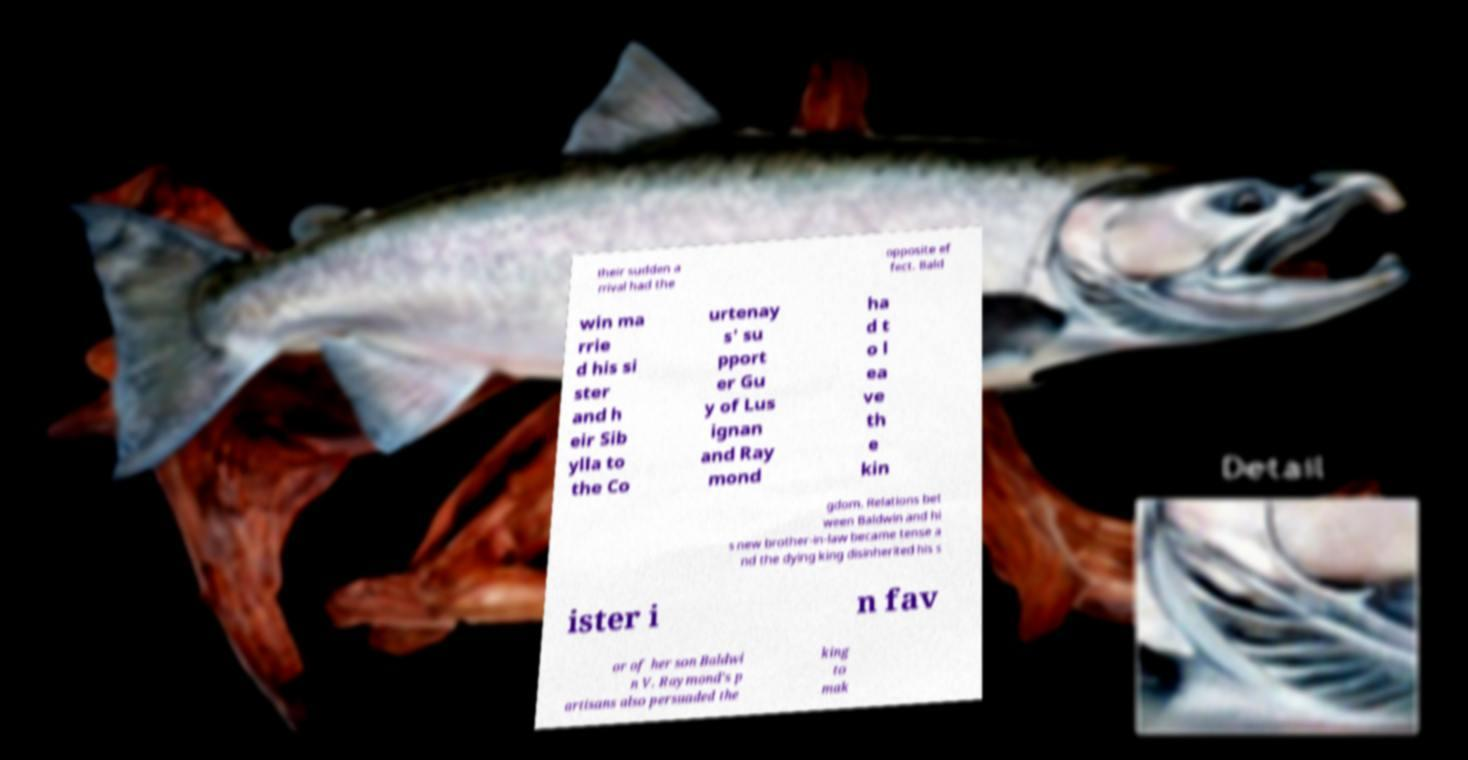I need the written content from this picture converted into text. Can you do that? their sudden a rrival had the opposite ef fect. Bald win ma rrie d his si ster and h eir Sib ylla to the Co urtenay s' su pport er Gu y of Lus ignan and Ray mond ha d t o l ea ve th e kin gdom. Relations bet ween Baldwin and hi s new brother-in-law became tense a nd the dying king disinherited his s ister i n fav or of her son Baldwi n V. Raymond's p artisans also persuaded the king to mak 